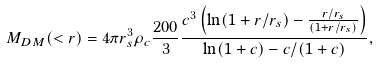<formula> <loc_0><loc_0><loc_500><loc_500>M _ { D M } ( < r ) = 4 \pi r _ { s } ^ { 3 } \rho _ { c } \frac { 2 0 0 } { 3 } \frac { c ^ { 3 } \left ( \ln ( 1 + r / r _ { s } ) - \frac { r / r _ { s } } { ( 1 + r / r _ { s } ) } \right ) } { \ln ( 1 + c ) - c / ( 1 + c ) } ,</formula> 